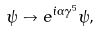<formula> <loc_0><loc_0><loc_500><loc_500>\psi \to e ^ { i \alpha \gamma ^ { 5 } } \psi ,</formula> 